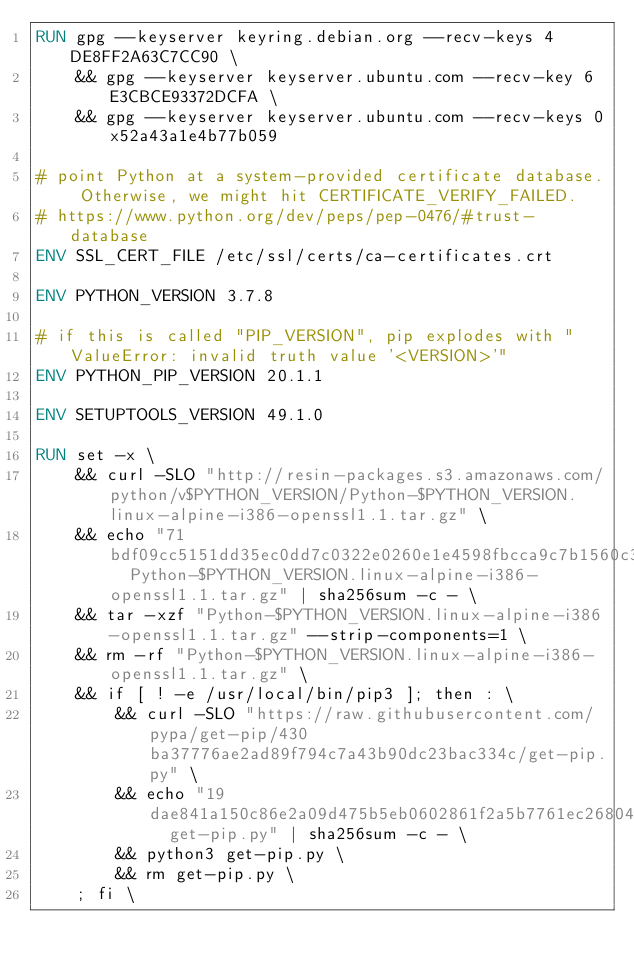Convert code to text. <code><loc_0><loc_0><loc_500><loc_500><_Dockerfile_>RUN gpg --keyserver keyring.debian.org --recv-keys 4DE8FF2A63C7CC90 \
	&& gpg --keyserver keyserver.ubuntu.com --recv-key 6E3CBCE93372DCFA \
	&& gpg --keyserver keyserver.ubuntu.com --recv-keys 0x52a43a1e4b77b059

# point Python at a system-provided certificate database. Otherwise, we might hit CERTIFICATE_VERIFY_FAILED.
# https://www.python.org/dev/peps/pep-0476/#trust-database
ENV SSL_CERT_FILE /etc/ssl/certs/ca-certificates.crt

ENV PYTHON_VERSION 3.7.8

# if this is called "PIP_VERSION", pip explodes with "ValueError: invalid truth value '<VERSION>'"
ENV PYTHON_PIP_VERSION 20.1.1

ENV SETUPTOOLS_VERSION 49.1.0

RUN set -x \
	&& curl -SLO "http://resin-packages.s3.amazonaws.com/python/v$PYTHON_VERSION/Python-$PYTHON_VERSION.linux-alpine-i386-openssl1.1.tar.gz" \
	&& echo "71bdf09cc5151dd35ec0dd7c0322e0260e1e4598fbcca9c7b1560c370f86516f  Python-$PYTHON_VERSION.linux-alpine-i386-openssl1.1.tar.gz" | sha256sum -c - \
	&& tar -xzf "Python-$PYTHON_VERSION.linux-alpine-i386-openssl1.1.tar.gz" --strip-components=1 \
	&& rm -rf "Python-$PYTHON_VERSION.linux-alpine-i386-openssl1.1.tar.gz" \
	&& if [ ! -e /usr/local/bin/pip3 ]; then : \
		&& curl -SLO "https://raw.githubusercontent.com/pypa/get-pip/430ba37776ae2ad89f794c7a43b90dc23bac334c/get-pip.py" \
		&& echo "19dae841a150c86e2a09d475b5eb0602861f2a5b7761ec268049a662dbd2bd0c  get-pip.py" | sha256sum -c - \
		&& python3 get-pip.py \
		&& rm get-pip.py \
	; fi \</code> 